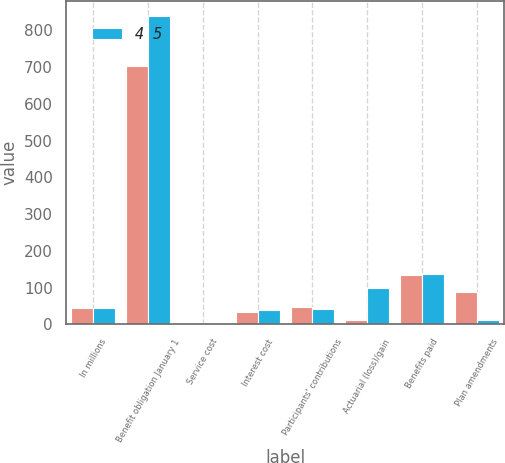<chart> <loc_0><loc_0><loc_500><loc_500><stacked_bar_chart><ecel><fcel>In millions<fcel>Benefit obligation January 1<fcel>Service cost<fcel>Interest cost<fcel>Participants' contributions<fcel>Actuarial (loss)/gain<fcel>Benefits paid<fcel>Plan amendments<nl><fcel>nan<fcel>44<fcel>703<fcel>2<fcel>33<fcel>46<fcel>12<fcel>133<fcel>88<nl><fcel>4 5<fcel>44<fcel>838<fcel>2<fcel>38<fcel>42<fcel>100<fcel>136<fcel>13<nl></chart> 